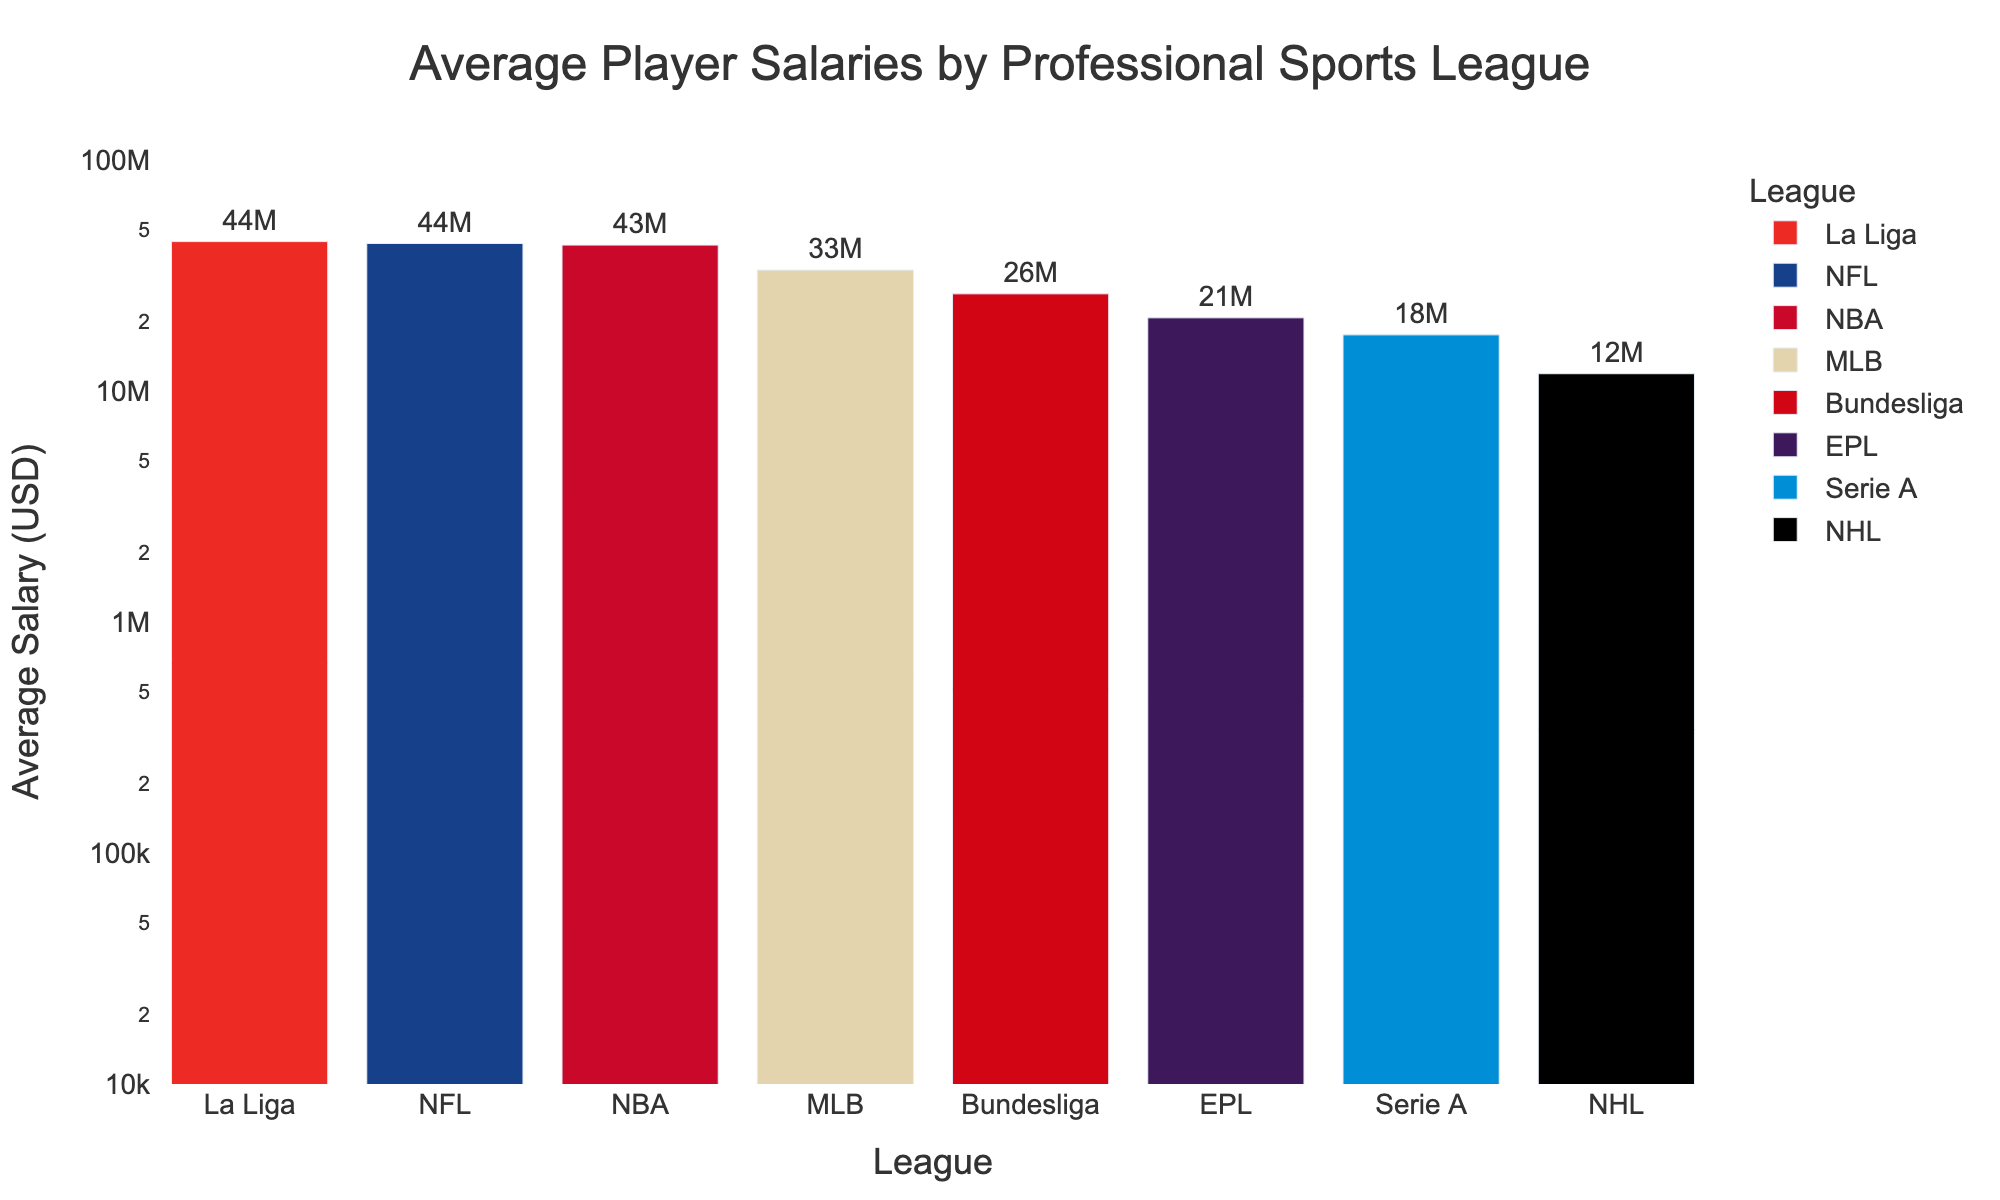What is the title of the plot? The title of the plot is located at the top of the figure. Titles generally give a quick overview of what the plot is about. In this case, it is "Average Player Salaries by Professional Sports League."
Answer: Average Player Salaries by Professional Sports League What does the y-axis represent in the plot? The labels next to the y-axis typically describe what that axis measures. In this case, the y-axis represents "Average Salary (USD)."
Answer: Average Salary (USD) Which league has the highest average player salary? By examining which bar in the bar plot reaches the highest point on the y-axis, we can identify the league with the highest average player salary.
Answer: La Liga Which two leagues have the closest average player salaries? Identify the heights of the bars that are close to each other. Upon close inspection, we find that the NHL's and EPL's bar heights are very close to each other.
Answer: NHL and EPL How does the NBA compare to the NFL in terms of average player salary? To compare, observe the heights of the bars for the NBA and NFL. The NBA's bar is slightly lower than the NFL's bar. Both bars are relatively close but the NFL is higher.
Answer: NFL has a higher average salary than the NBA What is approximately the range of the average salaries displayed in this plot? The range can be determined by finding the difference between the highest and lowest points on the y-axis in the log scale. La Liga is the highest at around 75 million and Serie A is the lowest at around 7 million.
Answer: 7 million to 75 million Which league has the third highest average player salary? By ordering the heights of the bars from tallest to shortest and finding the third in line, we see that Bundesliga has the third highest average salary.
Answer: Bundesliga Is the EPL's average salary greater or less than the MLB's? Compare the height of the EPL's bar to the height of the MLB's bar. The MLB's bar is taller than the EPL's bar.
Answer: Less Which league shows the most significant disparity between highest and lowest player salary within the league, based on average? (More speculative, suggest pattern recognition and consideration) While not directly shown in the bar itself, larger bars indicate greater overall variability in many cases. Aggregating into averages and considering La Liga's highest bar by a sizable margin suggests significant disparity.
Answer: La Liga What's the logarithmic range on the y-axis of this plot? By looking at the lowest and highest points on the y-axis and noting the scale indicated, the plot ranges from 10^4 to 10^8.
Answer: 10^4 to 10^8 